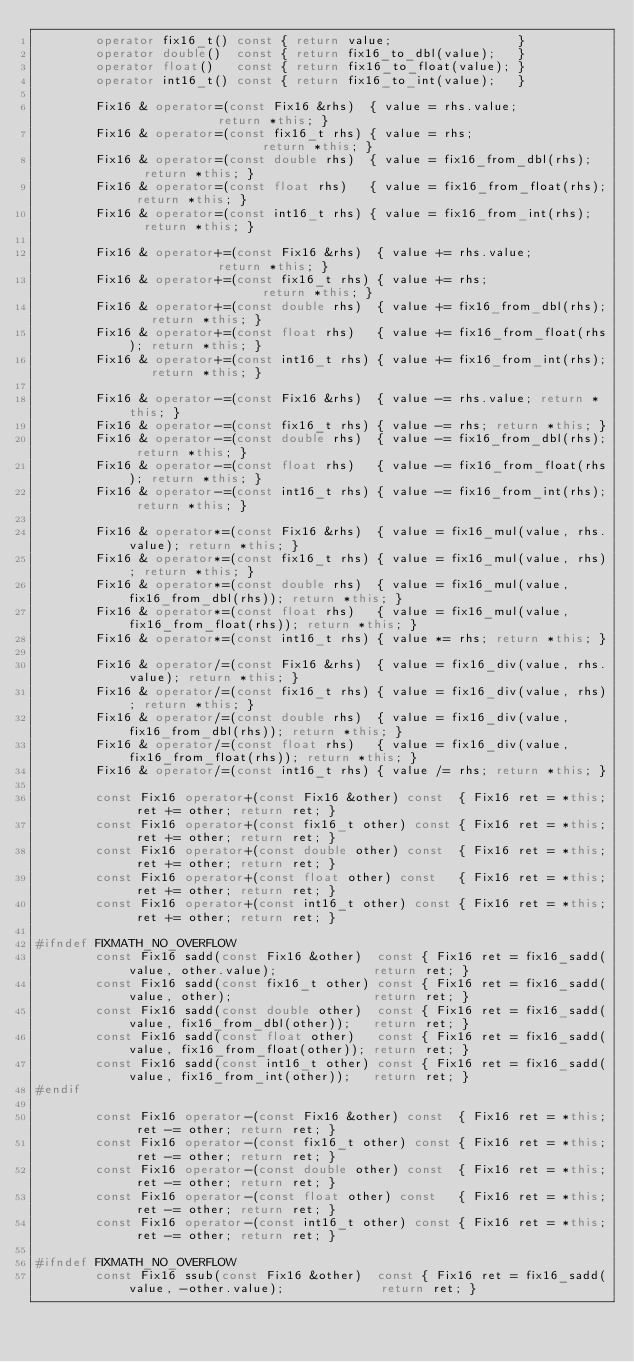<code> <loc_0><loc_0><loc_500><loc_500><_C++_>		operator fix16_t() const { return value;                 }
		operator double()  const { return fix16_to_dbl(value);   }
		operator float()   const { return fix16_to_float(value); }
		operator int16_t() const { return fix16_to_int(value);   }

		Fix16 & operator=(const Fix16 &rhs)  { value = rhs.value;             return *this; }
		Fix16 & operator=(const fix16_t rhs) { value = rhs;                   return *this; }
		Fix16 & operator=(const double rhs)  { value = fix16_from_dbl(rhs);   return *this; }
		Fix16 & operator=(const float rhs)   { value = fix16_from_float(rhs); return *this; }
		Fix16 & operator=(const int16_t rhs) { value = fix16_from_int(rhs);   return *this; }

		Fix16 & operator+=(const Fix16 &rhs)  { value += rhs.value;             return *this; }
		Fix16 & operator+=(const fix16_t rhs) { value += rhs;                   return *this; }
		Fix16 & operator+=(const double rhs)  { value += fix16_from_dbl(rhs);   return *this; }
		Fix16 & operator+=(const float rhs)   { value += fix16_from_float(rhs); return *this; }
		Fix16 & operator+=(const int16_t rhs) { value += fix16_from_int(rhs);   return *this; }

		Fix16 & operator-=(const Fix16 &rhs)  { value -= rhs.value; return *this; }
		Fix16 & operator-=(const fix16_t rhs) { value -= rhs; return *this; }
		Fix16 & operator-=(const double rhs)  { value -= fix16_from_dbl(rhs); return *this; }
		Fix16 & operator-=(const float rhs)   { value -= fix16_from_float(rhs); return *this; }
		Fix16 & operator-=(const int16_t rhs) { value -= fix16_from_int(rhs); return *this; }

		Fix16 & operator*=(const Fix16 &rhs)  { value = fix16_mul(value, rhs.value); return *this; }
		Fix16 & operator*=(const fix16_t rhs) { value = fix16_mul(value, rhs); return *this; }
		Fix16 & operator*=(const double rhs)  { value = fix16_mul(value, fix16_from_dbl(rhs)); return *this; }
		Fix16 & operator*=(const float rhs)   { value = fix16_mul(value, fix16_from_float(rhs)); return *this; }
		Fix16 & operator*=(const int16_t rhs) { value *= rhs; return *this; }

		Fix16 & operator/=(const Fix16 &rhs)  { value = fix16_div(value, rhs.value); return *this; }
		Fix16 & operator/=(const fix16_t rhs) { value = fix16_div(value, rhs); return *this; }
		Fix16 & operator/=(const double rhs)  { value = fix16_div(value, fix16_from_dbl(rhs)); return *this; }
		Fix16 & operator/=(const float rhs)   { value = fix16_div(value, fix16_from_float(rhs)); return *this; }
		Fix16 & operator/=(const int16_t rhs) { value /= rhs; return *this; }

		const Fix16 operator+(const Fix16 &other) const  { Fix16 ret = *this; ret += other; return ret; }
		const Fix16 operator+(const fix16_t other) const { Fix16 ret = *this; ret += other; return ret; }
		const Fix16 operator+(const double other) const  { Fix16 ret = *this; ret += other; return ret; }
		const Fix16 operator+(const float other) const   { Fix16 ret = *this; ret += other; return ret; }
		const Fix16 operator+(const int16_t other) const { Fix16 ret = *this; ret += other; return ret; }

#ifndef FIXMATH_NO_OVERFLOW
		const Fix16 sadd(const Fix16 &other)  const { Fix16 ret = fix16_sadd(value, other.value);             return ret; }
		const Fix16 sadd(const fix16_t other) const { Fix16 ret = fix16_sadd(value, other);                   return ret; }
		const Fix16 sadd(const double other)  const { Fix16 ret = fix16_sadd(value, fix16_from_dbl(other));   return ret; }
		const Fix16 sadd(const float other)   const { Fix16 ret = fix16_sadd(value, fix16_from_float(other)); return ret; }
		const Fix16 sadd(const int16_t other) const { Fix16 ret = fix16_sadd(value, fix16_from_int(other));   return ret; }
#endif

		const Fix16 operator-(const Fix16 &other) const  { Fix16 ret = *this; ret -= other; return ret; }
		const Fix16 operator-(const fix16_t other) const { Fix16 ret = *this; ret -= other; return ret; }
		const Fix16 operator-(const double other) const  { Fix16 ret = *this; ret -= other; return ret; }
		const Fix16 operator-(const float other) const   { Fix16 ret = *this; ret -= other; return ret; }
		const Fix16 operator-(const int16_t other) const { Fix16 ret = *this; ret -= other; return ret; }

#ifndef FIXMATH_NO_OVERFLOW
		const Fix16 ssub(const Fix16 &other)  const { Fix16 ret = fix16_sadd(value, -other.value);             return ret; }</code> 